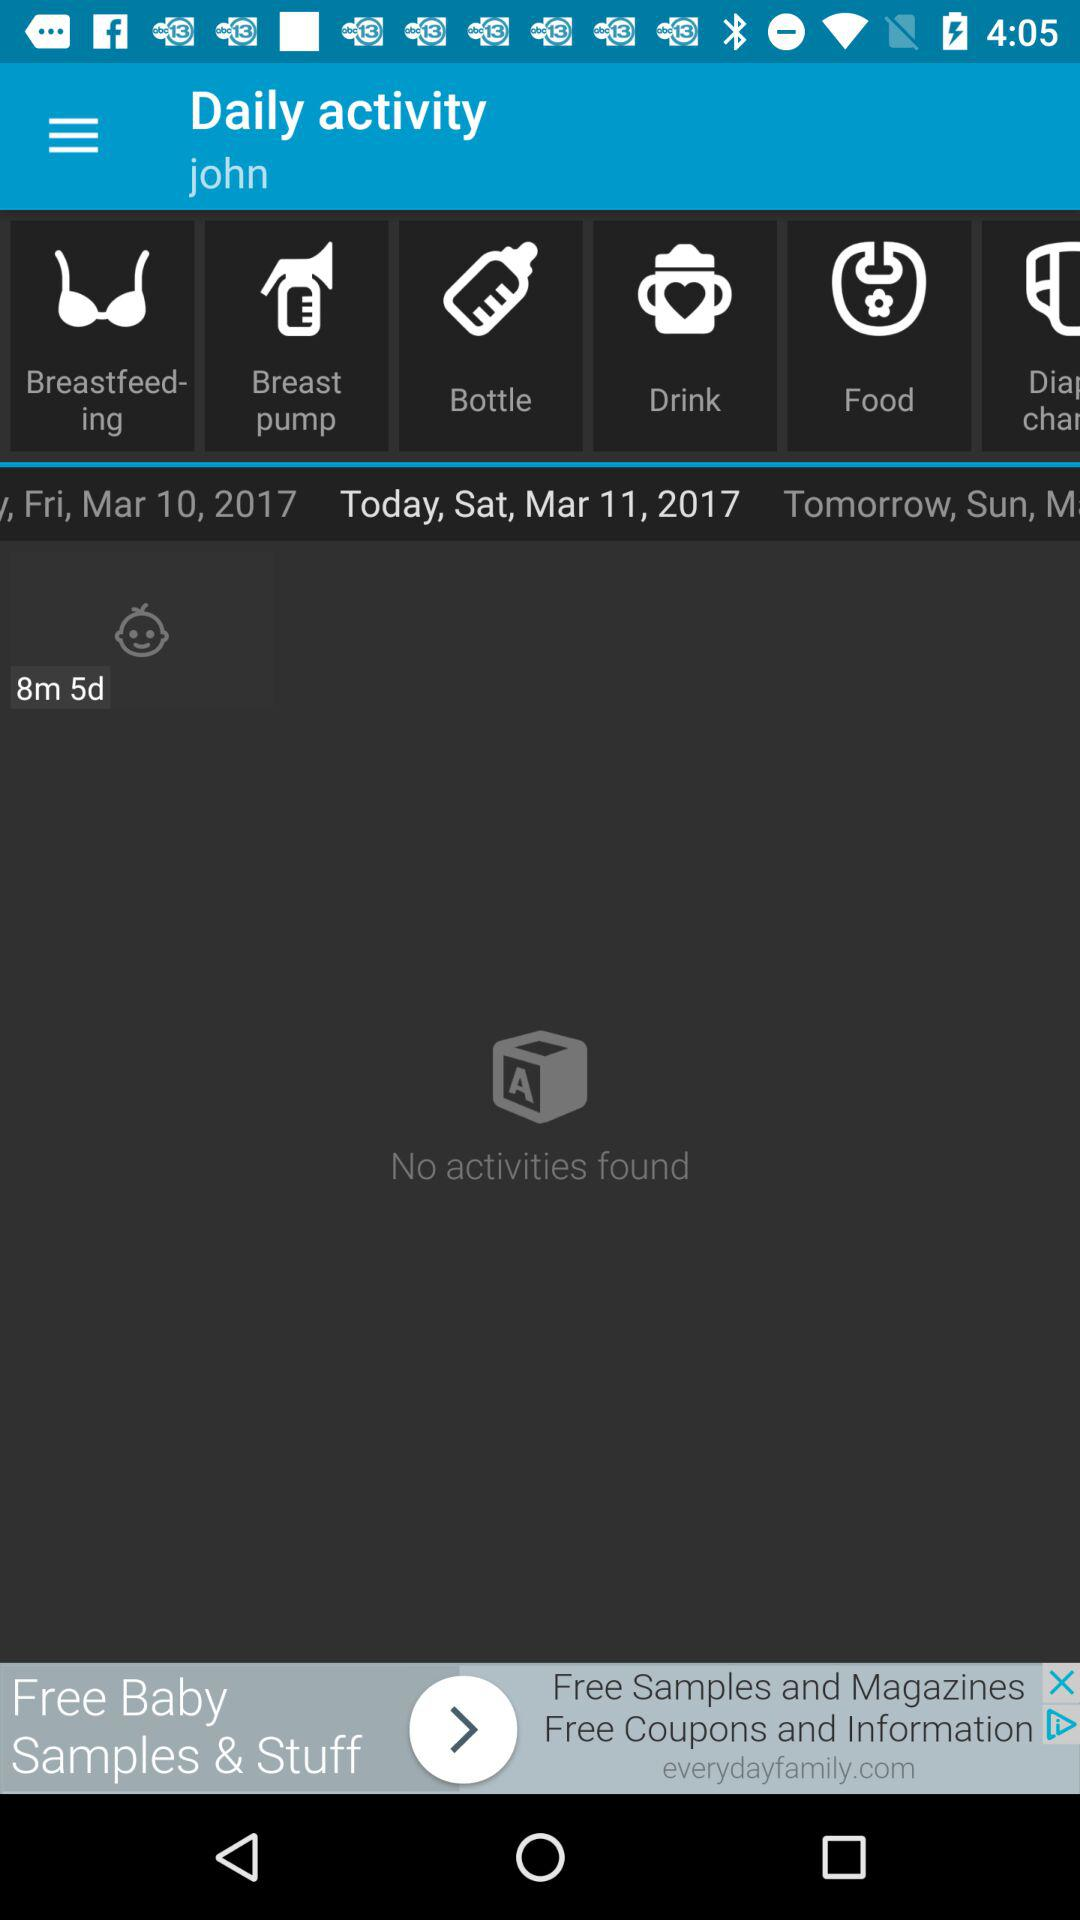What is today's date? Today's date is Saturday, March 11, 2017. 